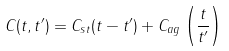Convert formula to latex. <formula><loc_0><loc_0><loc_500><loc_500>C ( t , t ^ { \prime } ) = C _ { s t } ( t - t ^ { \prime } ) + C _ { a g } \left ( \frac { t } { t ^ { \prime } } \right )</formula> 